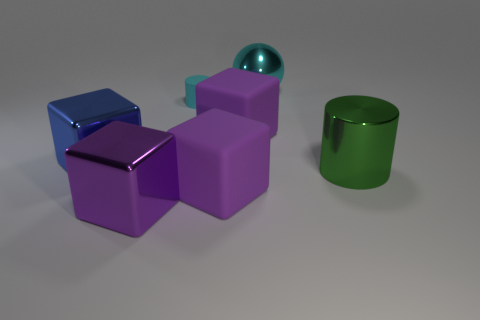What number of red matte spheres are there?
Your answer should be very brief. 0. How big is the cyan object that is in front of the shiny thing that is behind the large purple matte object that is behind the big blue metallic block?
Make the answer very short. Small. Is the rubber cylinder the same color as the sphere?
Provide a short and direct response. Yes. Is there any other thing that is the same size as the cyan matte cylinder?
Your response must be concise. No. There is a small cylinder; what number of purple cubes are left of it?
Offer a very short reply. 1. Are there an equal number of green metal things that are right of the tiny cyan matte cylinder and big green metallic cubes?
Your answer should be compact. No. What number of objects are either big cyan objects or brown rubber cylinders?
Make the answer very short. 1. Is there any other thing that has the same shape as the large blue shiny thing?
Your answer should be very brief. Yes. There is a big purple thing that is on the left side of the big purple matte block in front of the green object; what shape is it?
Your answer should be compact. Cube. There is a large purple object that is made of the same material as the big cylinder; what shape is it?
Offer a terse response. Cube. 